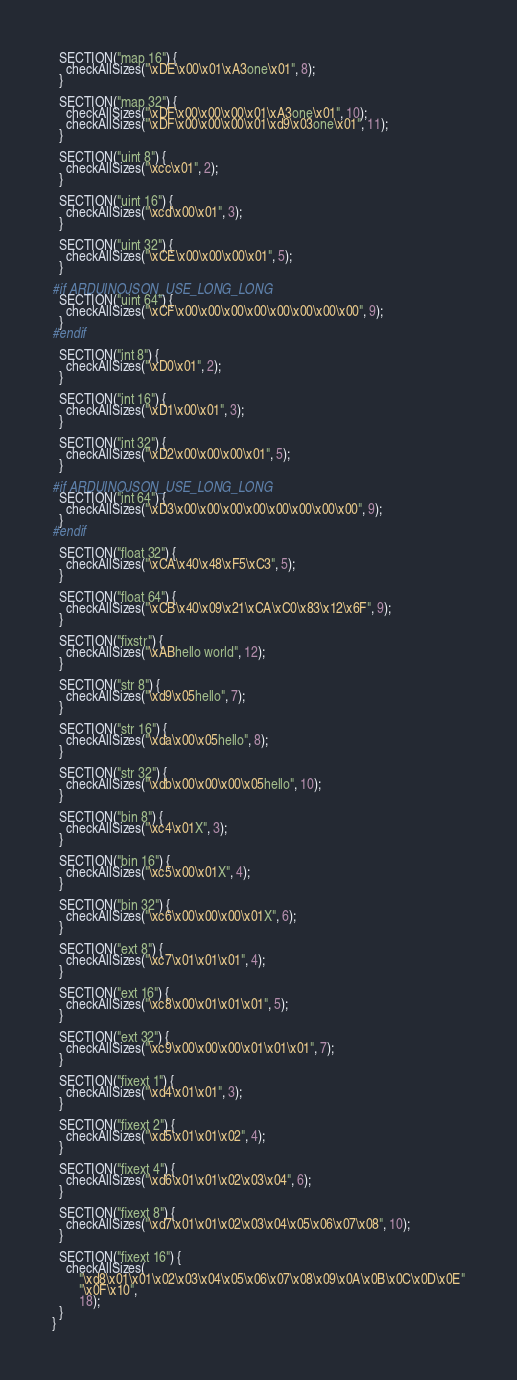<code> <loc_0><loc_0><loc_500><loc_500><_C++_>  SECTION("map 16") {
    checkAllSizes("\xDE\x00\x01\xA3one\x01", 8);
  }

  SECTION("map 32") {
    checkAllSizes("\xDF\x00\x00\x00\x01\xA3one\x01", 10);
    checkAllSizes("\xDF\x00\x00\x00\x01\xd9\x03one\x01", 11);
  }

  SECTION("uint 8") {
    checkAllSizes("\xcc\x01", 2);
  }

  SECTION("uint 16") {
    checkAllSizes("\xcd\x00\x01", 3);
  }

  SECTION("uint 32") {
    checkAllSizes("\xCE\x00\x00\x00\x01", 5);
  }

#if ARDUINOJSON_USE_LONG_LONG
  SECTION("uint 64") {
    checkAllSizes("\xCF\x00\x00\x00\x00\x00\x00\x00\x00", 9);
  }
#endif

  SECTION("int 8") {
    checkAllSizes("\xD0\x01", 2);
  }

  SECTION("int 16") {
    checkAllSizes("\xD1\x00\x01", 3);
  }

  SECTION("int 32") {
    checkAllSizes("\xD2\x00\x00\x00\x01", 5);
  }

#if ARDUINOJSON_USE_LONG_LONG
  SECTION("int 64") {
    checkAllSizes("\xD3\x00\x00\x00\x00\x00\x00\x00\x00", 9);
  }
#endif

  SECTION("float 32") {
    checkAllSizes("\xCA\x40\x48\xF5\xC3", 5);
  }

  SECTION("float 64") {
    checkAllSizes("\xCB\x40\x09\x21\xCA\xC0\x83\x12\x6F", 9);
  }

  SECTION("fixstr") {
    checkAllSizes("\xABhello world", 12);
  }

  SECTION("str 8") {
    checkAllSizes("\xd9\x05hello", 7);
  }

  SECTION("str 16") {
    checkAllSizes("\xda\x00\x05hello", 8);
  }

  SECTION("str 32") {
    checkAllSizes("\xdb\x00\x00\x00\x05hello", 10);
  }

  SECTION("bin 8") {
    checkAllSizes("\xc4\x01X", 3);
  }

  SECTION("bin 16") {
    checkAllSizes("\xc5\x00\x01X", 4);
  }

  SECTION("bin 32") {
    checkAllSizes("\xc6\x00\x00\x00\x01X", 6);
  }

  SECTION("ext 8") {
    checkAllSizes("\xc7\x01\x01\x01", 4);
  }

  SECTION("ext 16") {
    checkAllSizes("\xc8\x00\x01\x01\x01", 5);
  }

  SECTION("ext 32") {
    checkAllSizes("\xc9\x00\x00\x00\x01\x01\x01", 7);
  }

  SECTION("fixext 1") {
    checkAllSizes("\xd4\x01\x01", 3);
  }

  SECTION("fixext 2") {
    checkAllSizes("\xd5\x01\x01\x02", 4);
  }

  SECTION("fixext 4") {
    checkAllSizes("\xd6\x01\x01\x02\x03\x04", 6);
  }

  SECTION("fixext 8") {
    checkAllSizes("\xd7\x01\x01\x02\x03\x04\x05\x06\x07\x08", 10);
  }

  SECTION("fixext 16") {
    checkAllSizes(
        "\xd8\x01\x01\x02\x03\x04\x05\x06\x07\x08\x09\x0A\x0B\x0C\x0D\x0E"
        "\x0F\x10",
        18);
  }
}
</code> 